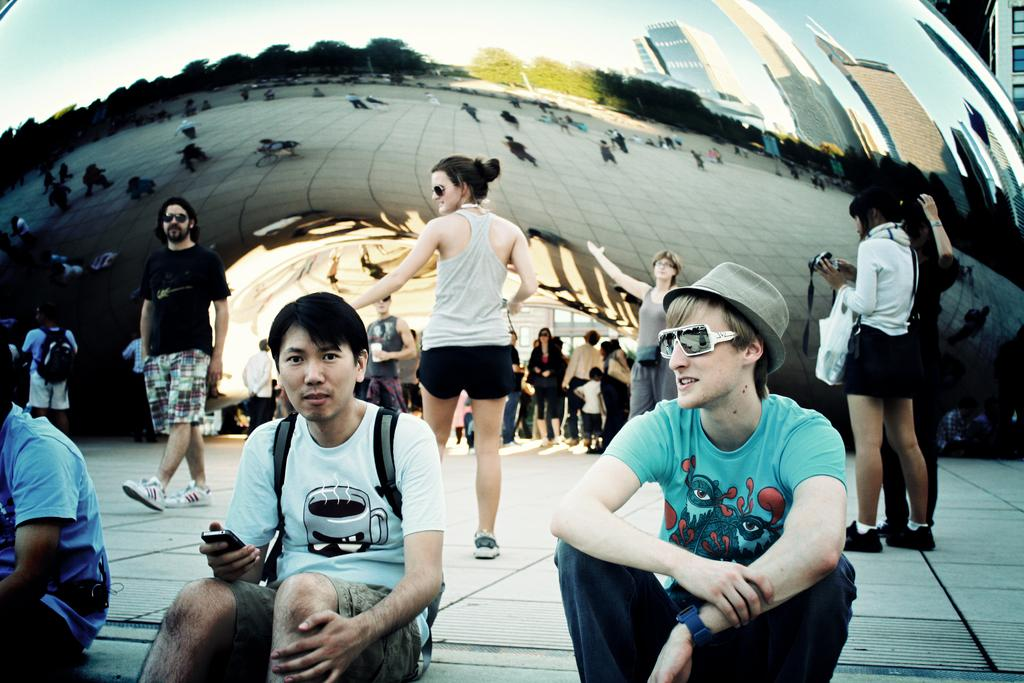What are the people in the image doing? There are people sitting on a pavement in the image. What is happening in the background of the image? There are people walking in the background of the image. What type of structure can be seen in the image? There is there any architecture visible? What type of plants can be seen growing on the planes in the image? There are no plants or planes present in the image. 